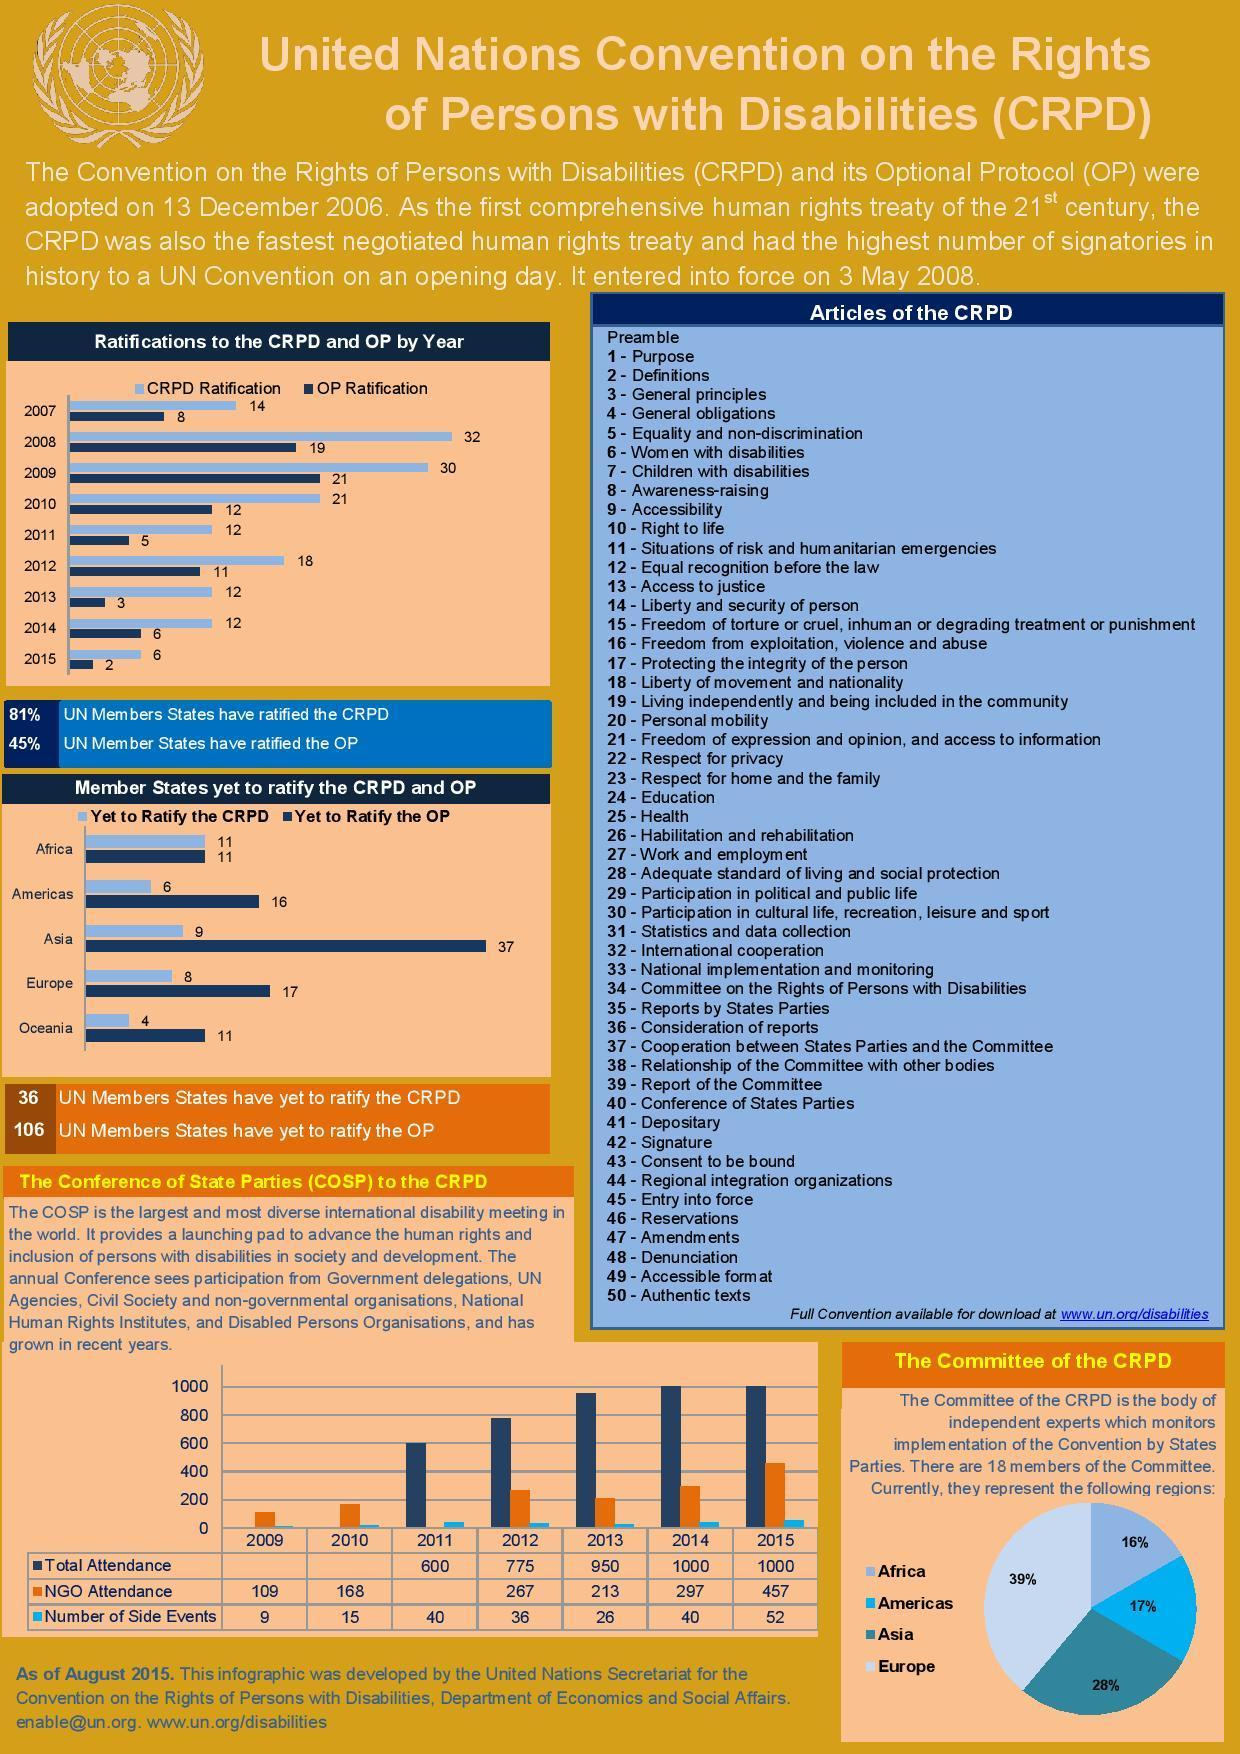What is the percentage difference in the States that have consented to the CRPD and OP?
Answer the question with a short phrase. 36% Which years in the table do not show any value for total attendance ? 2009, 2010 What is the figure or count in total attendance in the years 2014 and 2015? 1000 Which year recorded the lowest  OP ratification 2014, 2013, or 2015 ? 2015 What is percentage difference in representation of the Europe and Asia in the CRPD committee? 11% Which year has the second lowest CPRD approvals ? 2013 Which member state has the equal number of disapprovals to the CPRD and OP ? Africa Which year does not show a value for NGO attendance? 2011 Which member state has the second highest disapprovals of CRPD? Asia Which year recorded highest CRPD approvals 2007, 2008, or 2009? 2008 